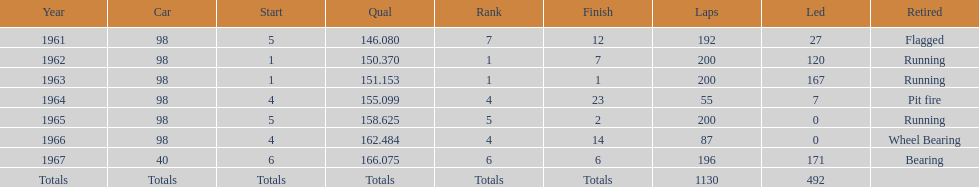Before 1965, when did jones achieve a number 5 position at the start of the indy 500? 1961. 